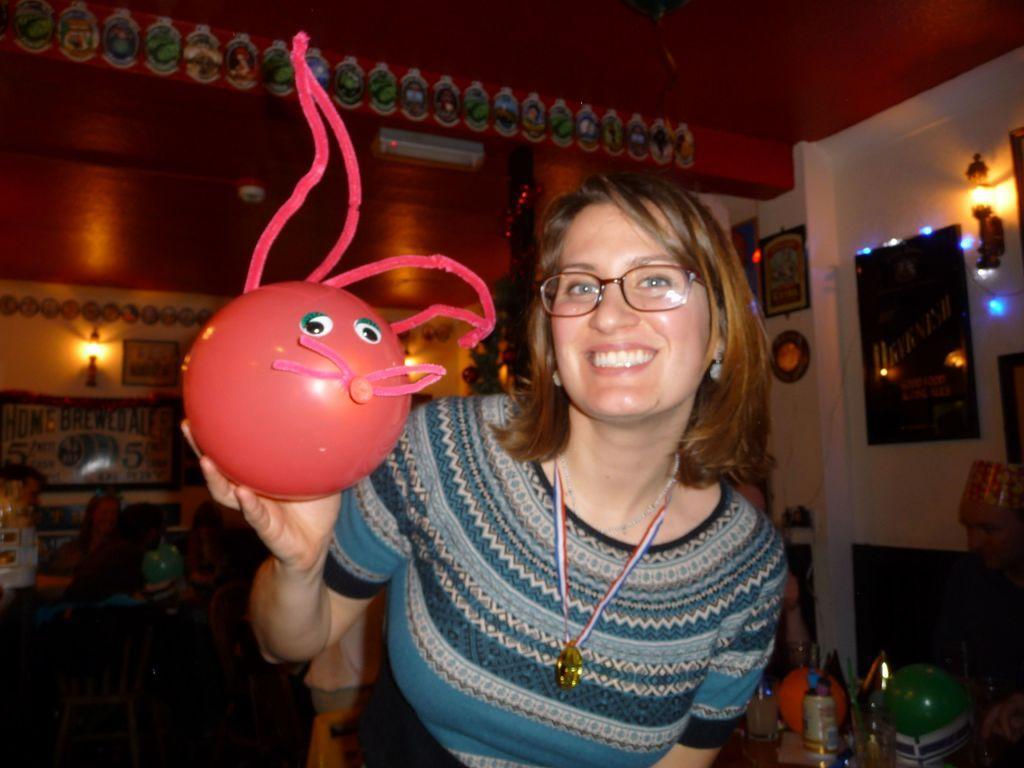Can you describe this image briefly? In this picture we can see a woman is holding an item and behind the woman there are some items and a wall with decorative items. 